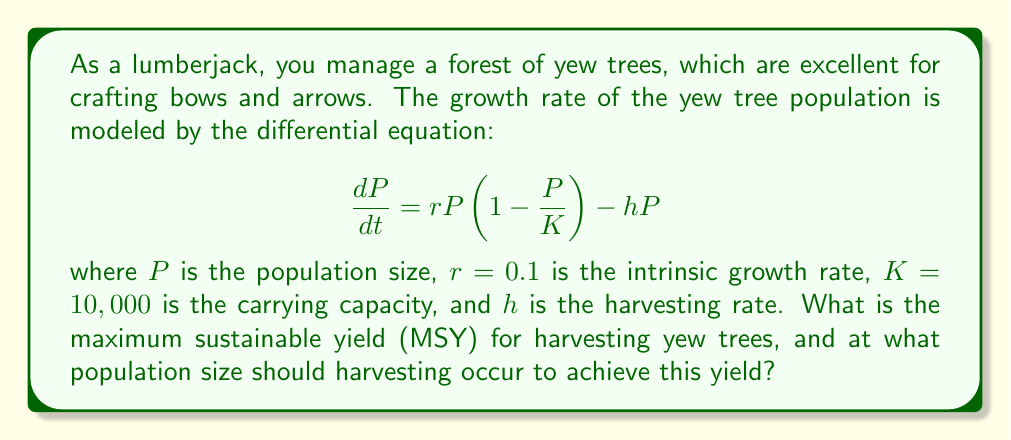Help me with this question. To solve this problem, we need to follow these steps:

1. Find the equilibrium population size:
   Set $\frac{dP}{dt} = 0$ and solve for $P$:
   
   $$0 = rP\left(1 - \frac{P}{K}\right) - hP$$
   $$hP = rP\left(1 - \frac{P}{K}\right)$$
   $$h = r\left(1 - \frac{P}{K}\right)$$
   $$P = K\left(1 - \frac{h}{r}\right)$$

2. Calculate the yield at equilibrium:
   Yield $Y = hP = hK\left(1 - \frac{h}{r}\right)$

3. Find the maximum sustainable yield:
   Differentiate $Y$ with respect to $h$ and set it to zero:
   
   $$\frac{dY}{dh} = K\left(1 - \frac{h}{r}\right) - K\frac{h}{r} = 0$$
   $$1 - \frac{h}{r} - \frac{h}{r} = 0$$
   $$1 - \frac{2h}{r} = 0$$
   $$h_{MSY} = \frac{r}{2} = 0.05$$

4. Calculate the population size at MSY:
   
   $$P_{MSY} = K\left(1 - \frac{h_{MSY}}{r}\right) = 10,000\left(1 - \frac{0.05}{0.1}\right) = 5,000$$

5. Calculate the maximum sustainable yield:
   
   $$Y_{MSY} = h_{MSY}P_{MSY} = 0.05 \times 5,000 = 250$$

Therefore, the maximum sustainable yield is 250 yew trees per time unit, and this occurs when the population size is 5,000 trees.
Answer: The maximum sustainable yield (MSY) is 250 yew trees per time unit, achieved when harvesting occurs at a population size of 5,000 trees. 